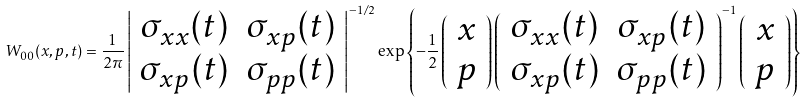<formula> <loc_0><loc_0><loc_500><loc_500>W _ { 0 0 } ( x , p , t ) = \frac { 1 } { 2 \pi } \left | \begin{array} { c c } \sigma _ { x x } ( t ) & \sigma _ { x p } ( t ) \\ \sigma _ { x p } ( t ) & \sigma _ { p p } ( t ) \end{array} \right | ^ { - 1 / 2 } \exp \left \{ - \frac { 1 } { 2 } \left ( \begin{array} { c } x \\ p \end{array} \right ) \left ( \begin{array} { c c } \sigma _ { x x } ( t ) & \sigma _ { x p } ( t ) \\ \sigma _ { x p } ( t ) & \sigma _ { p p } ( t ) \end{array} \right ) ^ { - 1 } \left ( \begin{array} { c } x \\ p \end{array} \right ) \right \}</formula> 